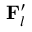Convert formula to latex. <formula><loc_0><loc_0><loc_500><loc_500>{ F } _ { l } ^ { \prime }</formula> 